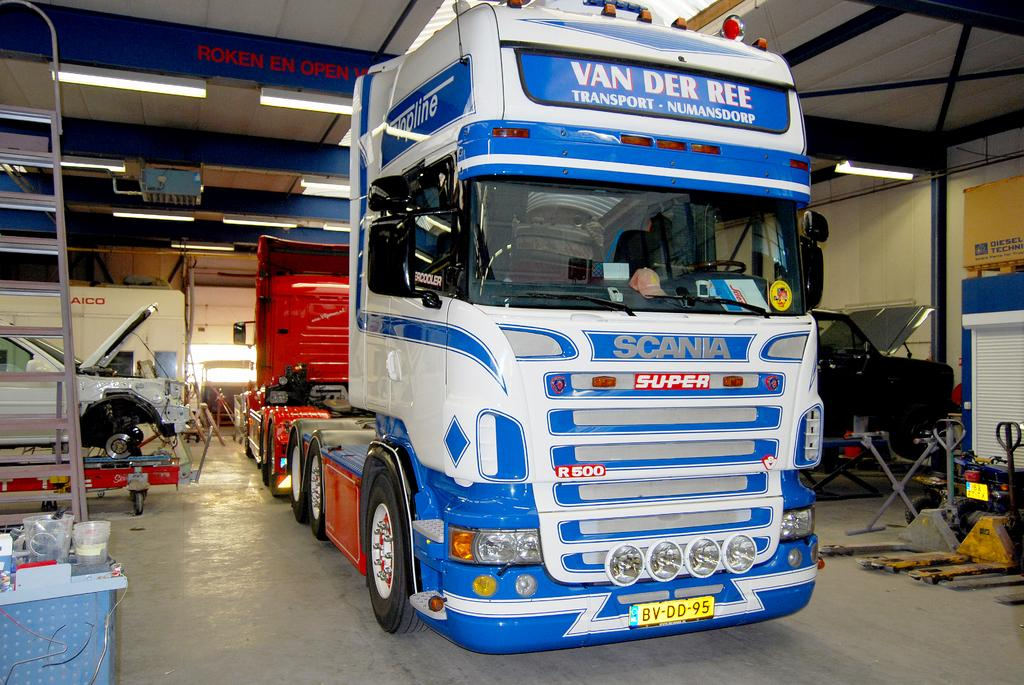What is the main subject of the image? The main subject of the image is a truck. Are there any other vehicles in the image? Yes, there are other vehicles in the image. What else can be seen around the vehicles? There are many other objects around the vehicles. What feature do the vehicles have in common? Lights are fitted to the roof of the vehicles. What type of wave can be seen crashing on the shore in the image? There is no wave or shore present in the image; it features vehicles with lights on their roofs. 